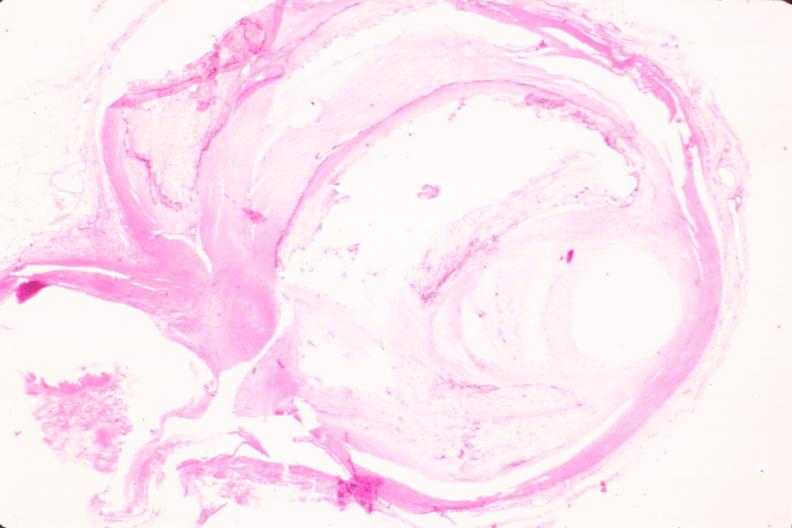does granulomata slide show coronary artery atherosclerosis?
Answer the question using a single word or phrase. No 